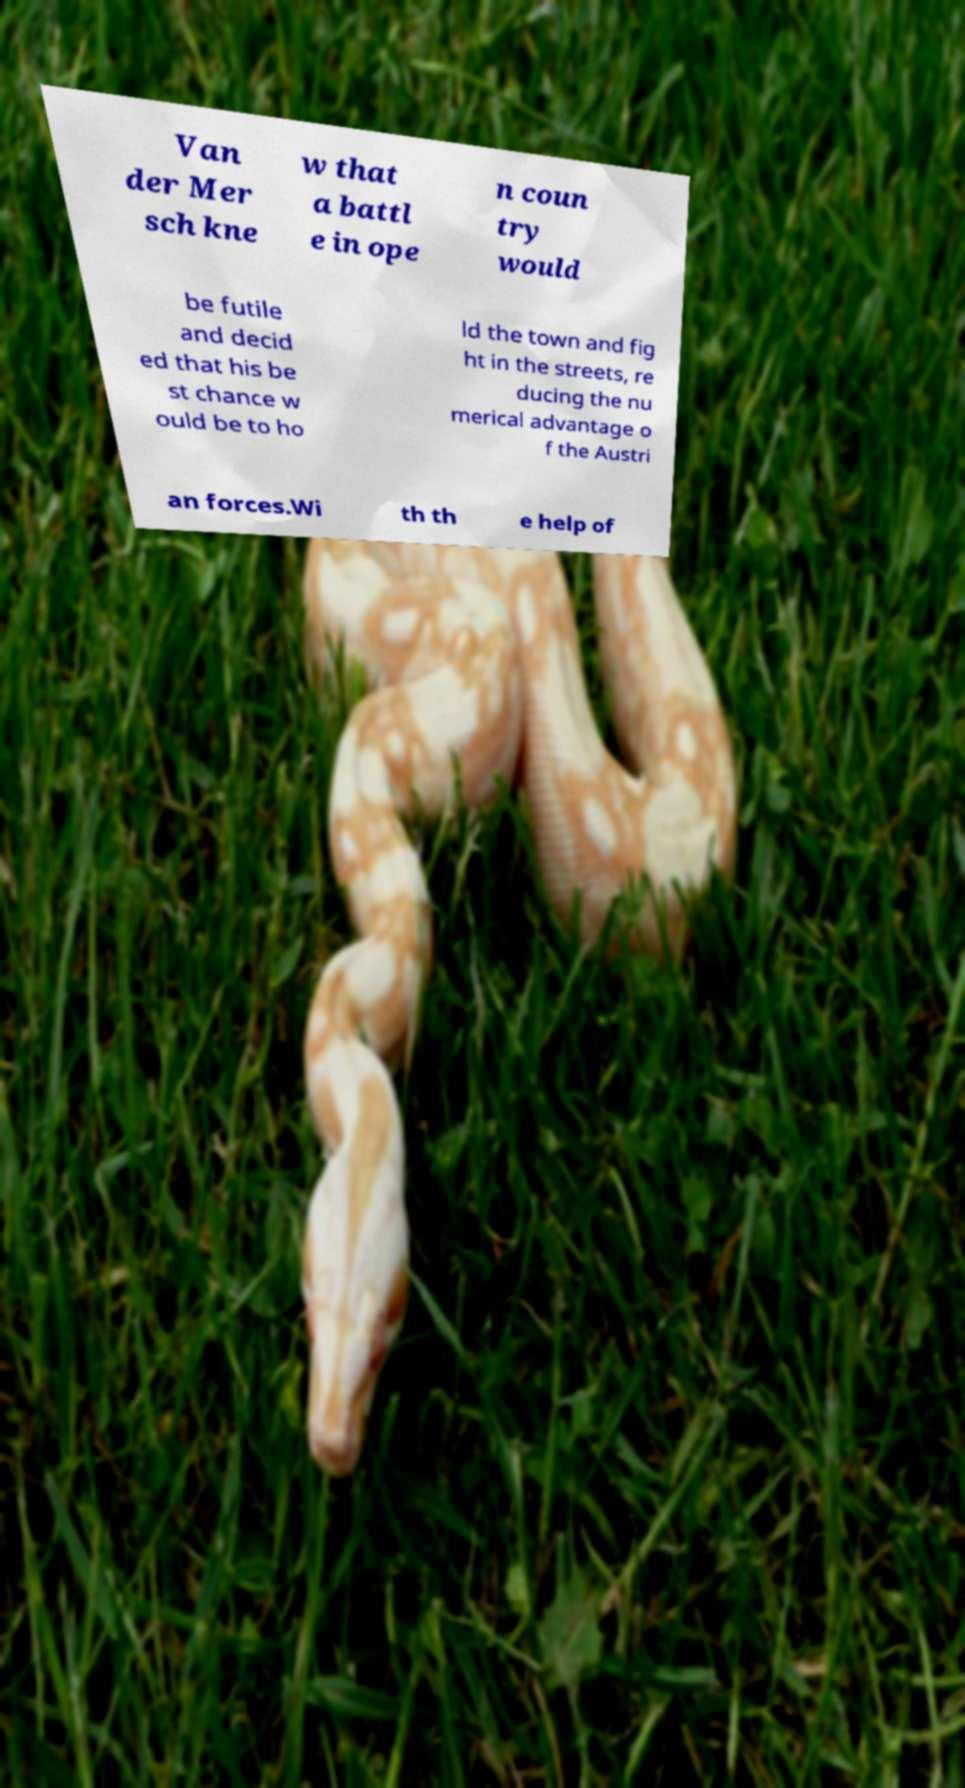Can you accurately transcribe the text from the provided image for me? Van der Mer sch kne w that a battl e in ope n coun try would be futile and decid ed that his be st chance w ould be to ho ld the town and fig ht in the streets, re ducing the nu merical advantage o f the Austri an forces.Wi th th e help of 